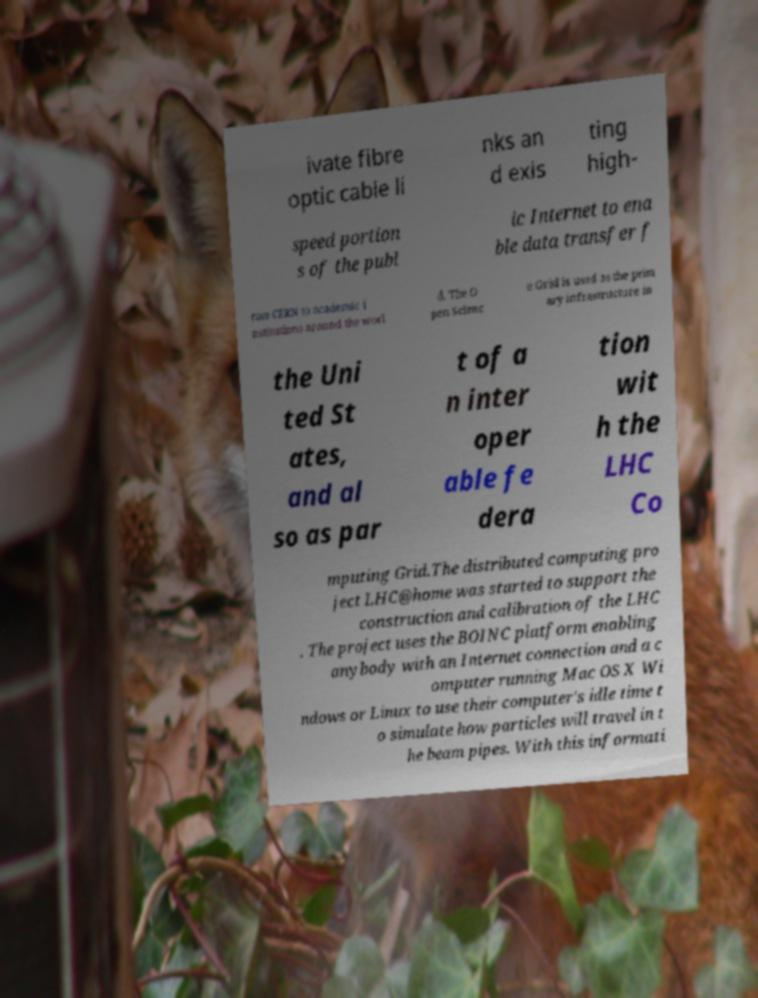I need the written content from this picture converted into text. Can you do that? ivate fibre optic cable li nks an d exis ting high- speed portion s of the publ ic Internet to ena ble data transfer f rom CERN to academic i nstitutions around the worl d. The O pen Scienc e Grid is used as the prim ary infrastructure in the Uni ted St ates, and al so as par t of a n inter oper able fe dera tion wit h the LHC Co mputing Grid.The distributed computing pro ject LHC@home was started to support the construction and calibration of the LHC . The project uses the BOINC platform enabling anybody with an Internet connection and a c omputer running Mac OS X Wi ndows or Linux to use their computer's idle time t o simulate how particles will travel in t he beam pipes. With this informati 